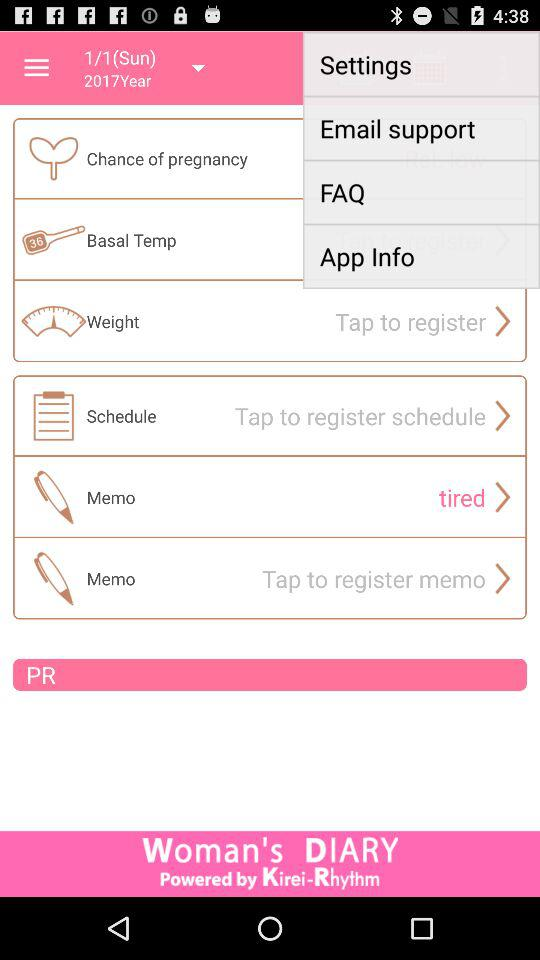Which is the selected year? The selected year is 2017. 